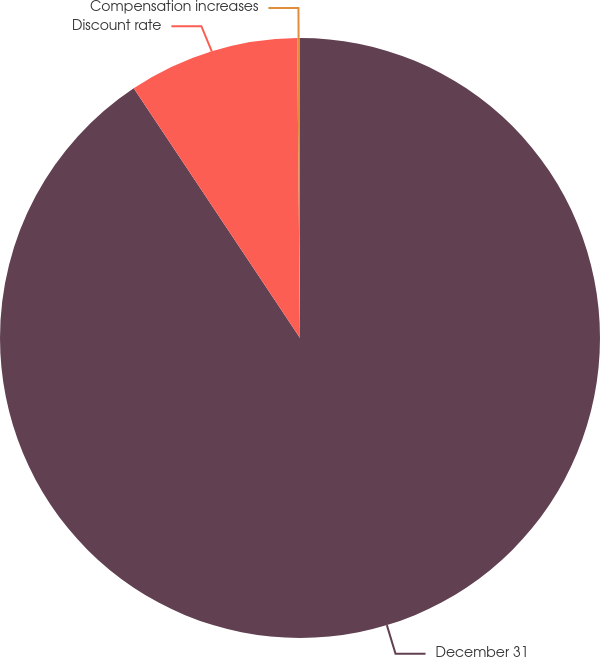Convert chart to OTSL. <chart><loc_0><loc_0><loc_500><loc_500><pie_chart><fcel>December 31<fcel>Discount rate<fcel>Compensation increases<nl><fcel>90.65%<fcel>9.2%<fcel>0.15%<nl></chart> 